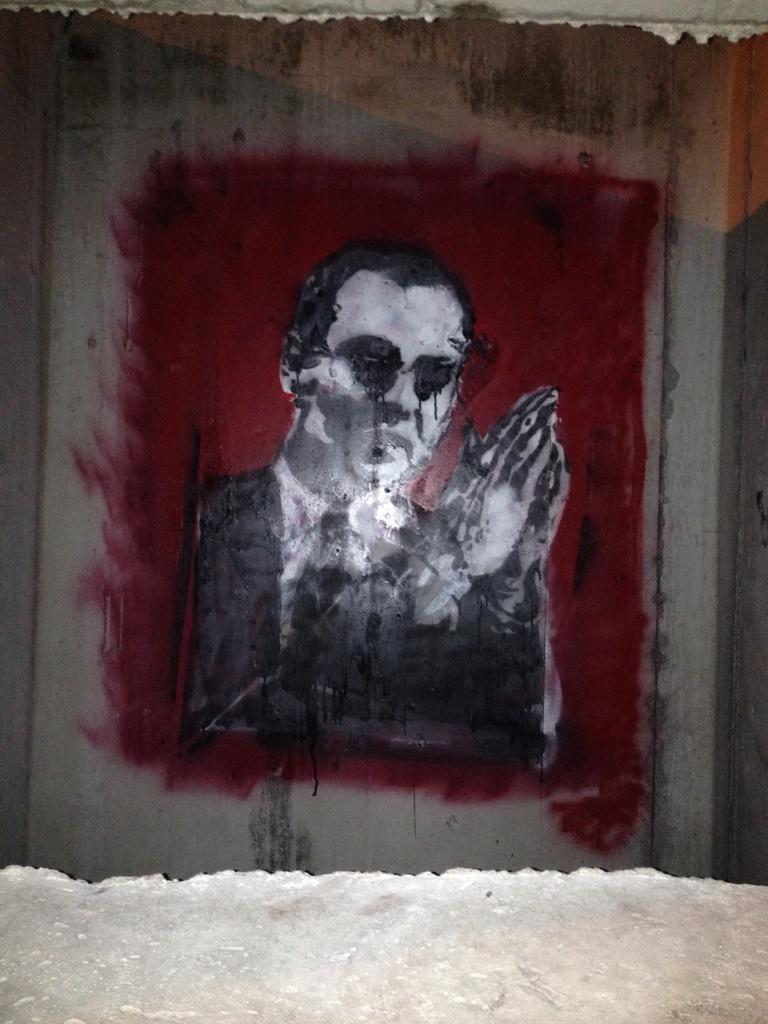What is depicted in the painting in the image? There is a painting of a man in the image. What is the man wearing in the painting? The man is wearing a black blazer in the painting. What color is the backdrop in the painting? The backdrop in the painting is red. What can be seen in the image besides the painting? There is a wall visible in the image. Is there a trail visible in the image? No, there is no trail visible in the image. What type of coat is the man wearing in the painting? The man is wearing a black blazer, not a coat, in the painting. 